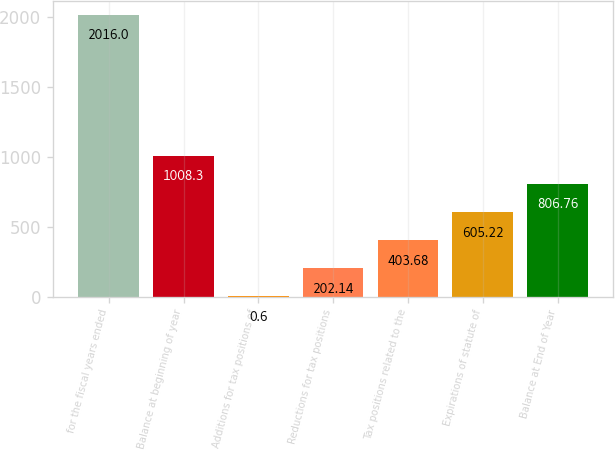Convert chart. <chart><loc_0><loc_0><loc_500><loc_500><bar_chart><fcel>for the fiscal years ended<fcel>Balance at beginning of year<fcel>Additions for tax positions of<fcel>Reductions for tax positions<fcel>Tax positions related to the<fcel>Expirations of statute of<fcel>Balance at End of Year<nl><fcel>2016<fcel>1008.3<fcel>0.6<fcel>202.14<fcel>403.68<fcel>605.22<fcel>806.76<nl></chart> 